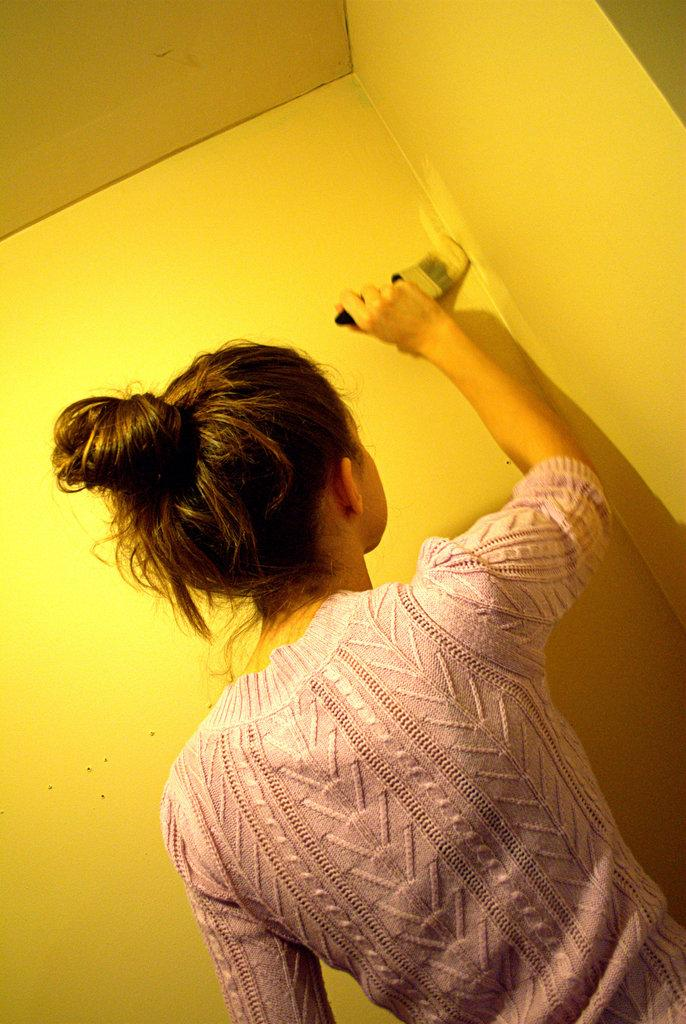Who is the main subject in the image? There is a lady in the image. What is the lady doing in the image? The lady is painting a wall. What tool is the lady using to paint the wall? The lady is using a brush to paint. What color is the wall in the background of the image? There is a yellow wall in the background of the image. What route is the sun taking in the image? The image does not show the sun or any route it might be taking. 